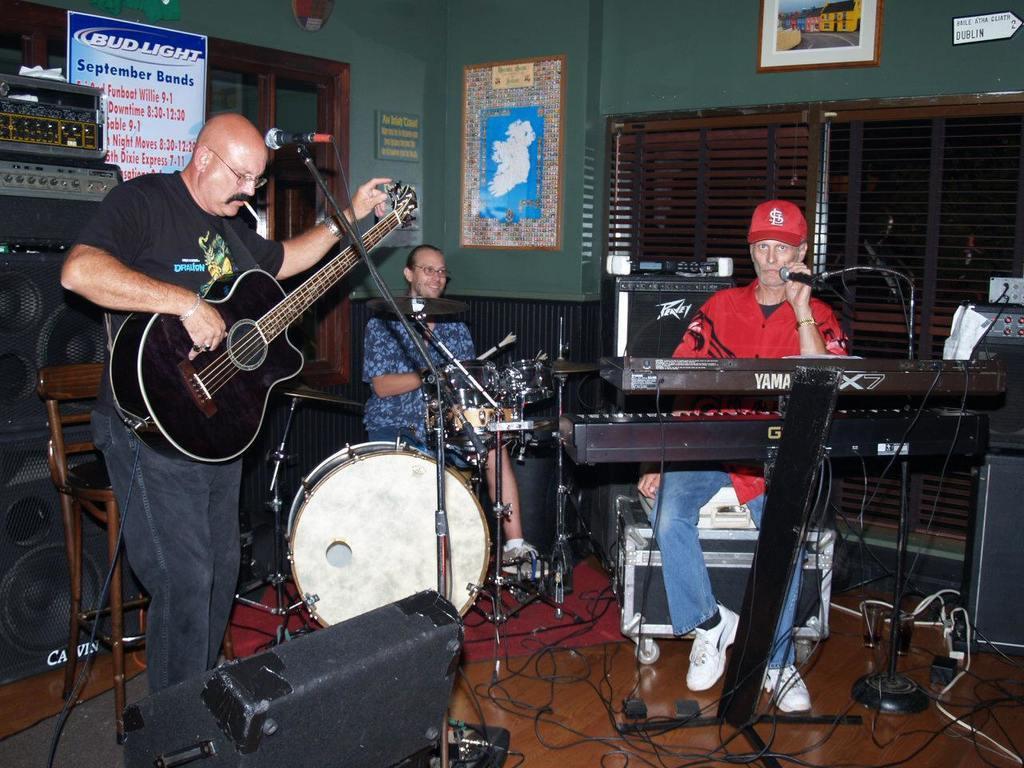How would you summarize this image in a sentence or two? In this image, there are three persons. In the left, the person is playing a guitar and standing. In the middle of the image, a person is playing a instrument and having a smile on his face. In the right middle of the image, a person is sitting and playing a keyboard. Both side of the wall there is a window and a wall is green in color. This image is taken in a studio. 